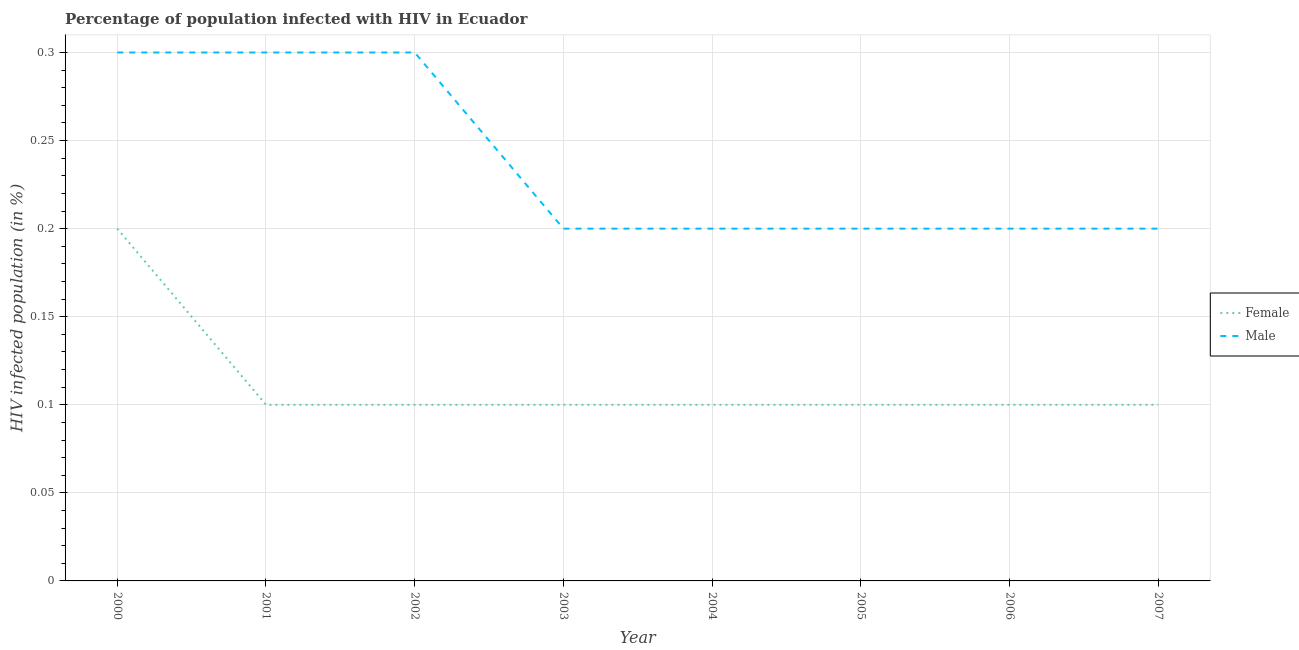How many different coloured lines are there?
Your answer should be compact. 2. Does the line corresponding to percentage of males who are infected with hiv intersect with the line corresponding to percentage of females who are infected with hiv?
Provide a short and direct response. No. Is the number of lines equal to the number of legend labels?
Your answer should be compact. Yes. What is the percentage of females who are infected with hiv in 2002?
Your answer should be very brief. 0.1. Across all years, what is the minimum percentage of males who are infected with hiv?
Make the answer very short. 0.2. In which year was the percentage of males who are infected with hiv maximum?
Your response must be concise. 2000. In which year was the percentage of males who are infected with hiv minimum?
Keep it short and to the point. 2003. What is the total percentage of males who are infected with hiv in the graph?
Your answer should be compact. 1.9. What is the difference between the percentage of males who are infected with hiv in 2003 and that in 2007?
Offer a very short reply. 0. What is the difference between the percentage of females who are infected with hiv in 2003 and the percentage of males who are infected with hiv in 2007?
Provide a succinct answer. -0.1. What is the average percentage of males who are infected with hiv per year?
Your answer should be compact. 0.24. Is the difference between the percentage of females who are infected with hiv in 2001 and 2005 greater than the difference between the percentage of males who are infected with hiv in 2001 and 2005?
Provide a succinct answer. No. What is the difference between the highest and the lowest percentage of females who are infected with hiv?
Keep it short and to the point. 0.1. In how many years, is the percentage of females who are infected with hiv greater than the average percentage of females who are infected with hiv taken over all years?
Give a very brief answer. 1. Is the sum of the percentage of females who are infected with hiv in 2001 and 2004 greater than the maximum percentage of males who are infected with hiv across all years?
Make the answer very short. No. Does the percentage of females who are infected with hiv monotonically increase over the years?
Your answer should be very brief. No. Is the percentage of males who are infected with hiv strictly greater than the percentage of females who are infected with hiv over the years?
Make the answer very short. Yes. Is the percentage of females who are infected with hiv strictly less than the percentage of males who are infected with hiv over the years?
Ensure brevity in your answer.  Yes. Are the values on the major ticks of Y-axis written in scientific E-notation?
Your answer should be very brief. No. Does the graph contain any zero values?
Ensure brevity in your answer.  No. How many legend labels are there?
Provide a succinct answer. 2. What is the title of the graph?
Make the answer very short. Percentage of population infected with HIV in Ecuador. Does "Education" appear as one of the legend labels in the graph?
Keep it short and to the point. No. What is the label or title of the Y-axis?
Your answer should be compact. HIV infected population (in %). What is the HIV infected population (in %) in Female in 2000?
Ensure brevity in your answer.  0.2. What is the HIV infected population (in %) of Male in 2000?
Give a very brief answer. 0.3. What is the HIV infected population (in %) of Female in 2001?
Keep it short and to the point. 0.1. What is the HIV infected population (in %) in Male in 2002?
Offer a terse response. 0.3. What is the HIV infected population (in %) of Female in 2003?
Provide a short and direct response. 0.1. What is the HIV infected population (in %) of Male in 2003?
Offer a terse response. 0.2. What is the HIV infected population (in %) of Female in 2004?
Your answer should be very brief. 0.1. What is the HIV infected population (in %) in Female in 2005?
Ensure brevity in your answer.  0.1. What is the HIV infected population (in %) of Male in 2005?
Give a very brief answer. 0.2. What is the HIV infected population (in %) of Female in 2006?
Ensure brevity in your answer.  0.1. What is the HIV infected population (in %) in Male in 2007?
Your answer should be very brief. 0.2. Across all years, what is the maximum HIV infected population (in %) in Male?
Offer a very short reply. 0.3. Across all years, what is the minimum HIV infected population (in %) in Female?
Provide a short and direct response. 0.1. Across all years, what is the minimum HIV infected population (in %) in Male?
Your answer should be very brief. 0.2. What is the difference between the HIV infected population (in %) in Female in 2000 and that in 2001?
Ensure brevity in your answer.  0.1. What is the difference between the HIV infected population (in %) of Female in 2000 and that in 2002?
Offer a terse response. 0.1. What is the difference between the HIV infected population (in %) of Male in 2000 and that in 2002?
Provide a short and direct response. 0. What is the difference between the HIV infected population (in %) of Female in 2000 and that in 2003?
Offer a terse response. 0.1. What is the difference between the HIV infected population (in %) in Male in 2000 and that in 2003?
Offer a very short reply. 0.1. What is the difference between the HIV infected population (in %) of Male in 2000 and that in 2004?
Offer a very short reply. 0.1. What is the difference between the HIV infected population (in %) of Male in 2000 and that in 2005?
Your answer should be very brief. 0.1. What is the difference between the HIV infected population (in %) in Female in 2001 and that in 2002?
Ensure brevity in your answer.  0. What is the difference between the HIV infected population (in %) of Male in 2001 and that in 2003?
Provide a succinct answer. 0.1. What is the difference between the HIV infected population (in %) in Male in 2001 and that in 2004?
Provide a succinct answer. 0.1. What is the difference between the HIV infected population (in %) in Male in 2001 and that in 2005?
Give a very brief answer. 0.1. What is the difference between the HIV infected population (in %) of Female in 2001 and that in 2006?
Offer a terse response. 0. What is the difference between the HIV infected population (in %) in Male in 2001 and that in 2006?
Provide a succinct answer. 0.1. What is the difference between the HIV infected population (in %) of Male in 2001 and that in 2007?
Your response must be concise. 0.1. What is the difference between the HIV infected population (in %) in Female in 2002 and that in 2004?
Your answer should be very brief. 0. What is the difference between the HIV infected population (in %) in Female in 2002 and that in 2005?
Offer a terse response. 0. What is the difference between the HIV infected population (in %) in Female in 2003 and that in 2004?
Provide a succinct answer. 0. What is the difference between the HIV infected population (in %) of Female in 2003 and that in 2005?
Ensure brevity in your answer.  0. What is the difference between the HIV infected population (in %) of Male in 2003 and that in 2006?
Provide a succinct answer. 0. What is the difference between the HIV infected population (in %) in Male in 2003 and that in 2007?
Your response must be concise. 0. What is the difference between the HIV infected population (in %) in Male in 2004 and that in 2005?
Your answer should be compact. 0. What is the difference between the HIV infected population (in %) in Female in 2004 and that in 2007?
Your response must be concise. 0. What is the difference between the HIV infected population (in %) in Male in 2005 and that in 2006?
Offer a terse response. 0. What is the difference between the HIV infected population (in %) of Male in 2005 and that in 2007?
Your answer should be very brief. 0. What is the difference between the HIV infected population (in %) of Male in 2006 and that in 2007?
Provide a short and direct response. 0. What is the difference between the HIV infected population (in %) in Female in 2000 and the HIV infected population (in %) in Male in 2003?
Your answer should be compact. 0. What is the difference between the HIV infected population (in %) of Female in 2000 and the HIV infected population (in %) of Male in 2007?
Provide a succinct answer. 0. What is the difference between the HIV infected population (in %) in Female in 2002 and the HIV infected population (in %) in Male in 2005?
Ensure brevity in your answer.  -0.1. What is the difference between the HIV infected population (in %) in Female in 2002 and the HIV infected population (in %) in Male in 2007?
Provide a short and direct response. -0.1. What is the difference between the HIV infected population (in %) in Female in 2003 and the HIV infected population (in %) in Male in 2004?
Provide a short and direct response. -0.1. What is the difference between the HIV infected population (in %) in Female in 2003 and the HIV infected population (in %) in Male in 2005?
Your answer should be compact. -0.1. What is the difference between the HIV infected population (in %) in Female in 2003 and the HIV infected population (in %) in Male in 2006?
Make the answer very short. -0.1. What is the difference between the HIV infected population (in %) in Female in 2003 and the HIV infected population (in %) in Male in 2007?
Your answer should be compact. -0.1. What is the difference between the HIV infected population (in %) of Female in 2004 and the HIV infected population (in %) of Male in 2007?
Your response must be concise. -0.1. What is the difference between the HIV infected population (in %) of Female in 2005 and the HIV infected population (in %) of Male in 2006?
Keep it short and to the point. -0.1. What is the difference between the HIV infected population (in %) in Female in 2005 and the HIV infected population (in %) in Male in 2007?
Offer a terse response. -0.1. What is the average HIV infected population (in %) of Female per year?
Ensure brevity in your answer.  0.11. What is the average HIV infected population (in %) of Male per year?
Your answer should be compact. 0.24. In the year 2000, what is the difference between the HIV infected population (in %) of Female and HIV infected population (in %) of Male?
Your answer should be compact. -0.1. In the year 2001, what is the difference between the HIV infected population (in %) of Female and HIV infected population (in %) of Male?
Your answer should be compact. -0.2. In the year 2002, what is the difference between the HIV infected population (in %) of Female and HIV infected population (in %) of Male?
Your answer should be very brief. -0.2. In the year 2004, what is the difference between the HIV infected population (in %) of Female and HIV infected population (in %) of Male?
Provide a succinct answer. -0.1. In the year 2005, what is the difference between the HIV infected population (in %) in Female and HIV infected population (in %) in Male?
Provide a succinct answer. -0.1. In the year 2006, what is the difference between the HIV infected population (in %) of Female and HIV infected population (in %) of Male?
Your response must be concise. -0.1. What is the ratio of the HIV infected population (in %) in Female in 2000 to that in 2001?
Give a very brief answer. 2. What is the ratio of the HIV infected population (in %) in Male in 2000 to that in 2001?
Give a very brief answer. 1. What is the ratio of the HIV infected population (in %) of Male in 2000 to that in 2002?
Your answer should be compact. 1. What is the ratio of the HIV infected population (in %) in Male in 2000 to that in 2004?
Ensure brevity in your answer.  1.5. What is the ratio of the HIV infected population (in %) of Male in 2000 to that in 2005?
Your answer should be compact. 1.5. What is the ratio of the HIV infected population (in %) of Female in 2000 to that in 2006?
Provide a short and direct response. 2. What is the ratio of the HIV infected population (in %) of Female in 2001 to that in 2002?
Your response must be concise. 1. What is the ratio of the HIV infected population (in %) in Female in 2001 to that in 2003?
Your answer should be very brief. 1. What is the ratio of the HIV infected population (in %) in Male in 2001 to that in 2003?
Keep it short and to the point. 1.5. What is the ratio of the HIV infected population (in %) in Male in 2001 to that in 2004?
Your answer should be very brief. 1.5. What is the ratio of the HIV infected population (in %) of Male in 2001 to that in 2005?
Your response must be concise. 1.5. What is the ratio of the HIV infected population (in %) in Male in 2001 to that in 2006?
Provide a succinct answer. 1.5. What is the ratio of the HIV infected population (in %) in Female in 2001 to that in 2007?
Ensure brevity in your answer.  1. What is the ratio of the HIV infected population (in %) of Female in 2002 to that in 2007?
Ensure brevity in your answer.  1. What is the ratio of the HIV infected population (in %) in Male in 2002 to that in 2007?
Provide a short and direct response. 1.5. What is the ratio of the HIV infected population (in %) in Female in 2003 to that in 2004?
Offer a terse response. 1. What is the ratio of the HIV infected population (in %) of Female in 2003 to that in 2005?
Your response must be concise. 1. What is the ratio of the HIV infected population (in %) in Female in 2003 to that in 2006?
Give a very brief answer. 1. What is the ratio of the HIV infected population (in %) in Male in 2003 to that in 2006?
Your answer should be very brief. 1. What is the ratio of the HIV infected population (in %) of Female in 2003 to that in 2007?
Give a very brief answer. 1. What is the ratio of the HIV infected population (in %) of Male in 2004 to that in 2005?
Give a very brief answer. 1. What is the ratio of the HIV infected population (in %) in Male in 2004 to that in 2006?
Keep it short and to the point. 1. What is the ratio of the HIV infected population (in %) of Male in 2004 to that in 2007?
Provide a short and direct response. 1. What is the ratio of the HIV infected population (in %) of Male in 2005 to that in 2006?
Your answer should be very brief. 1. What is the ratio of the HIV infected population (in %) in Male in 2006 to that in 2007?
Give a very brief answer. 1. What is the difference between the highest and the second highest HIV infected population (in %) of Female?
Make the answer very short. 0.1. 